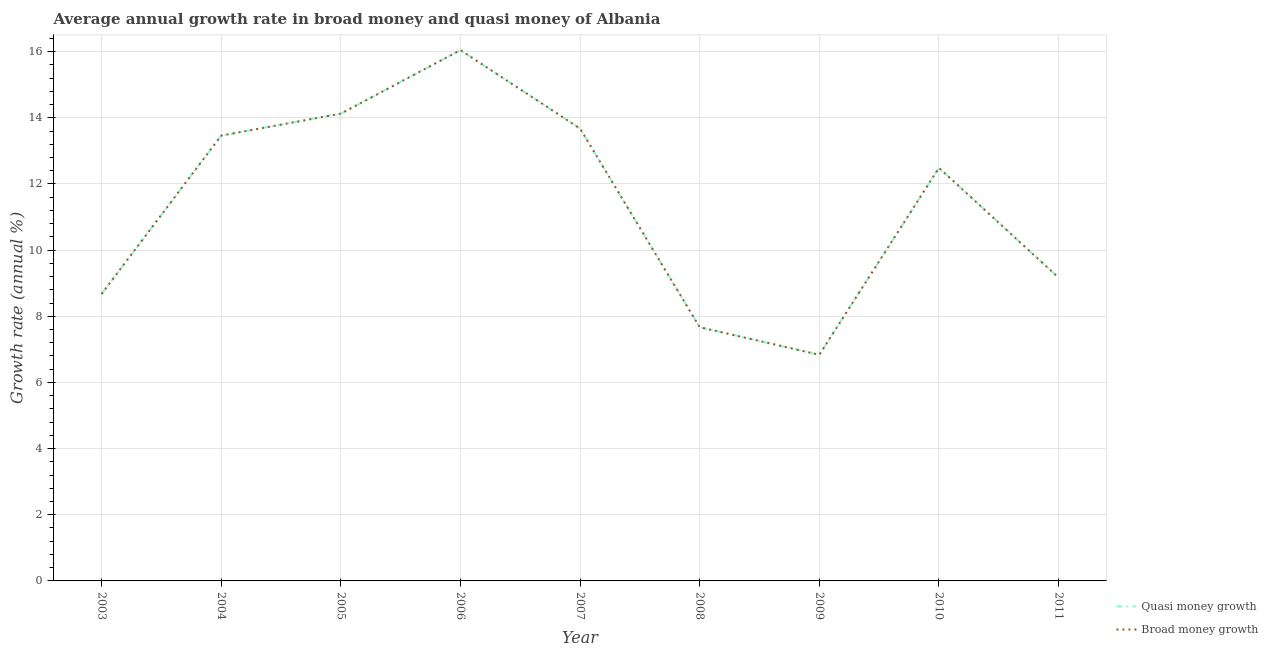Does the line corresponding to annual growth rate in quasi money intersect with the line corresponding to annual growth rate in broad money?
Provide a succinct answer. Yes. Is the number of lines equal to the number of legend labels?
Your response must be concise. Yes. What is the annual growth rate in quasi money in 2009?
Ensure brevity in your answer.  6.84. Across all years, what is the maximum annual growth rate in quasi money?
Offer a terse response. 16.05. Across all years, what is the minimum annual growth rate in quasi money?
Your response must be concise. 6.84. In which year was the annual growth rate in broad money minimum?
Your answer should be compact. 2009. What is the total annual growth rate in quasi money in the graph?
Offer a terse response. 102.14. What is the difference between the annual growth rate in quasi money in 2003 and that in 2004?
Your answer should be compact. -4.79. What is the difference between the annual growth rate in broad money in 2010 and the annual growth rate in quasi money in 2008?
Keep it short and to the point. 4.82. What is the average annual growth rate in broad money per year?
Your response must be concise. 11.35. In the year 2008, what is the difference between the annual growth rate in broad money and annual growth rate in quasi money?
Provide a short and direct response. 0. In how many years, is the annual growth rate in broad money greater than 13.6 %?
Offer a terse response. 3. What is the ratio of the annual growth rate in broad money in 2008 to that in 2009?
Ensure brevity in your answer.  1.12. Is the annual growth rate in quasi money in 2003 less than that in 2009?
Give a very brief answer. No. What is the difference between the highest and the second highest annual growth rate in quasi money?
Your answer should be compact. 1.92. What is the difference between the highest and the lowest annual growth rate in broad money?
Make the answer very short. 9.21. Does the annual growth rate in broad money monotonically increase over the years?
Make the answer very short. No. Is the annual growth rate in broad money strictly greater than the annual growth rate in quasi money over the years?
Keep it short and to the point. No. Is the annual growth rate in quasi money strictly less than the annual growth rate in broad money over the years?
Provide a short and direct response. No. How many lines are there?
Provide a short and direct response. 2. Does the graph contain any zero values?
Offer a very short reply. No. How many legend labels are there?
Ensure brevity in your answer.  2. How are the legend labels stacked?
Your answer should be very brief. Vertical. What is the title of the graph?
Provide a succinct answer. Average annual growth rate in broad money and quasi money of Albania. What is the label or title of the Y-axis?
Make the answer very short. Growth rate (annual %). What is the Growth rate (annual %) in Quasi money growth in 2003?
Ensure brevity in your answer.  8.67. What is the Growth rate (annual %) in Broad money growth in 2003?
Make the answer very short. 8.67. What is the Growth rate (annual %) of Quasi money growth in 2004?
Ensure brevity in your answer.  13.46. What is the Growth rate (annual %) in Broad money growth in 2004?
Offer a very short reply. 13.46. What is the Growth rate (annual %) of Quasi money growth in 2005?
Ensure brevity in your answer.  14.13. What is the Growth rate (annual %) of Broad money growth in 2005?
Offer a very short reply. 14.13. What is the Growth rate (annual %) in Quasi money growth in 2006?
Ensure brevity in your answer.  16.05. What is the Growth rate (annual %) of Broad money growth in 2006?
Provide a succinct answer. 16.05. What is the Growth rate (annual %) in Quasi money growth in 2007?
Provide a succinct answer. 13.67. What is the Growth rate (annual %) in Broad money growth in 2007?
Your response must be concise. 13.67. What is the Growth rate (annual %) in Quasi money growth in 2008?
Your response must be concise. 7.67. What is the Growth rate (annual %) of Broad money growth in 2008?
Your answer should be very brief. 7.67. What is the Growth rate (annual %) of Quasi money growth in 2009?
Keep it short and to the point. 6.84. What is the Growth rate (annual %) of Broad money growth in 2009?
Your answer should be very brief. 6.84. What is the Growth rate (annual %) of Quasi money growth in 2010?
Make the answer very short. 12.49. What is the Growth rate (annual %) of Broad money growth in 2010?
Give a very brief answer. 12.49. What is the Growth rate (annual %) of Quasi money growth in 2011?
Give a very brief answer. 9.17. What is the Growth rate (annual %) of Broad money growth in 2011?
Offer a very short reply. 9.17. Across all years, what is the maximum Growth rate (annual %) in Quasi money growth?
Keep it short and to the point. 16.05. Across all years, what is the maximum Growth rate (annual %) of Broad money growth?
Give a very brief answer. 16.05. Across all years, what is the minimum Growth rate (annual %) of Quasi money growth?
Make the answer very short. 6.84. Across all years, what is the minimum Growth rate (annual %) in Broad money growth?
Give a very brief answer. 6.84. What is the total Growth rate (annual %) in Quasi money growth in the graph?
Provide a succinct answer. 102.14. What is the total Growth rate (annual %) of Broad money growth in the graph?
Offer a very short reply. 102.14. What is the difference between the Growth rate (annual %) of Quasi money growth in 2003 and that in 2004?
Make the answer very short. -4.79. What is the difference between the Growth rate (annual %) of Broad money growth in 2003 and that in 2004?
Ensure brevity in your answer.  -4.79. What is the difference between the Growth rate (annual %) in Quasi money growth in 2003 and that in 2005?
Your response must be concise. -5.45. What is the difference between the Growth rate (annual %) of Broad money growth in 2003 and that in 2005?
Your response must be concise. -5.45. What is the difference between the Growth rate (annual %) of Quasi money growth in 2003 and that in 2006?
Keep it short and to the point. -7.37. What is the difference between the Growth rate (annual %) in Broad money growth in 2003 and that in 2006?
Make the answer very short. -7.37. What is the difference between the Growth rate (annual %) in Quasi money growth in 2003 and that in 2007?
Keep it short and to the point. -5. What is the difference between the Growth rate (annual %) of Broad money growth in 2003 and that in 2007?
Your answer should be compact. -5. What is the difference between the Growth rate (annual %) of Quasi money growth in 2003 and that in 2008?
Give a very brief answer. 1. What is the difference between the Growth rate (annual %) in Broad money growth in 2003 and that in 2008?
Offer a terse response. 1. What is the difference between the Growth rate (annual %) of Quasi money growth in 2003 and that in 2009?
Offer a terse response. 1.84. What is the difference between the Growth rate (annual %) of Broad money growth in 2003 and that in 2009?
Make the answer very short. 1.84. What is the difference between the Growth rate (annual %) of Quasi money growth in 2003 and that in 2010?
Offer a terse response. -3.81. What is the difference between the Growth rate (annual %) in Broad money growth in 2003 and that in 2010?
Your response must be concise. -3.81. What is the difference between the Growth rate (annual %) in Quasi money growth in 2003 and that in 2011?
Keep it short and to the point. -0.49. What is the difference between the Growth rate (annual %) in Broad money growth in 2003 and that in 2011?
Provide a short and direct response. -0.49. What is the difference between the Growth rate (annual %) of Quasi money growth in 2004 and that in 2005?
Give a very brief answer. -0.66. What is the difference between the Growth rate (annual %) of Broad money growth in 2004 and that in 2005?
Offer a terse response. -0.66. What is the difference between the Growth rate (annual %) of Quasi money growth in 2004 and that in 2006?
Offer a terse response. -2.58. What is the difference between the Growth rate (annual %) of Broad money growth in 2004 and that in 2006?
Your answer should be compact. -2.58. What is the difference between the Growth rate (annual %) in Quasi money growth in 2004 and that in 2007?
Offer a very short reply. -0.21. What is the difference between the Growth rate (annual %) of Broad money growth in 2004 and that in 2007?
Offer a terse response. -0.21. What is the difference between the Growth rate (annual %) of Quasi money growth in 2004 and that in 2008?
Offer a terse response. 5.79. What is the difference between the Growth rate (annual %) of Broad money growth in 2004 and that in 2008?
Make the answer very short. 5.79. What is the difference between the Growth rate (annual %) in Quasi money growth in 2004 and that in 2009?
Your answer should be very brief. 6.62. What is the difference between the Growth rate (annual %) in Broad money growth in 2004 and that in 2009?
Your answer should be compact. 6.62. What is the difference between the Growth rate (annual %) of Quasi money growth in 2004 and that in 2010?
Offer a very short reply. 0.97. What is the difference between the Growth rate (annual %) of Broad money growth in 2004 and that in 2010?
Provide a short and direct response. 0.97. What is the difference between the Growth rate (annual %) of Quasi money growth in 2004 and that in 2011?
Provide a succinct answer. 4.29. What is the difference between the Growth rate (annual %) of Broad money growth in 2004 and that in 2011?
Offer a terse response. 4.29. What is the difference between the Growth rate (annual %) of Quasi money growth in 2005 and that in 2006?
Give a very brief answer. -1.92. What is the difference between the Growth rate (annual %) of Broad money growth in 2005 and that in 2006?
Offer a terse response. -1.92. What is the difference between the Growth rate (annual %) in Quasi money growth in 2005 and that in 2007?
Offer a terse response. 0.45. What is the difference between the Growth rate (annual %) in Broad money growth in 2005 and that in 2007?
Offer a terse response. 0.45. What is the difference between the Growth rate (annual %) in Quasi money growth in 2005 and that in 2008?
Ensure brevity in your answer.  6.46. What is the difference between the Growth rate (annual %) in Broad money growth in 2005 and that in 2008?
Your answer should be compact. 6.46. What is the difference between the Growth rate (annual %) in Quasi money growth in 2005 and that in 2009?
Offer a very short reply. 7.29. What is the difference between the Growth rate (annual %) in Broad money growth in 2005 and that in 2009?
Keep it short and to the point. 7.29. What is the difference between the Growth rate (annual %) of Quasi money growth in 2005 and that in 2010?
Keep it short and to the point. 1.64. What is the difference between the Growth rate (annual %) of Broad money growth in 2005 and that in 2010?
Your answer should be very brief. 1.64. What is the difference between the Growth rate (annual %) of Quasi money growth in 2005 and that in 2011?
Your response must be concise. 4.96. What is the difference between the Growth rate (annual %) in Broad money growth in 2005 and that in 2011?
Your response must be concise. 4.96. What is the difference between the Growth rate (annual %) in Quasi money growth in 2006 and that in 2007?
Provide a short and direct response. 2.37. What is the difference between the Growth rate (annual %) in Broad money growth in 2006 and that in 2007?
Make the answer very short. 2.37. What is the difference between the Growth rate (annual %) in Quasi money growth in 2006 and that in 2008?
Give a very brief answer. 8.38. What is the difference between the Growth rate (annual %) of Broad money growth in 2006 and that in 2008?
Your response must be concise. 8.38. What is the difference between the Growth rate (annual %) of Quasi money growth in 2006 and that in 2009?
Give a very brief answer. 9.21. What is the difference between the Growth rate (annual %) of Broad money growth in 2006 and that in 2009?
Offer a terse response. 9.21. What is the difference between the Growth rate (annual %) in Quasi money growth in 2006 and that in 2010?
Your answer should be very brief. 3.56. What is the difference between the Growth rate (annual %) of Broad money growth in 2006 and that in 2010?
Your answer should be compact. 3.56. What is the difference between the Growth rate (annual %) in Quasi money growth in 2006 and that in 2011?
Keep it short and to the point. 6.88. What is the difference between the Growth rate (annual %) of Broad money growth in 2006 and that in 2011?
Give a very brief answer. 6.88. What is the difference between the Growth rate (annual %) in Quasi money growth in 2007 and that in 2008?
Your answer should be compact. 6.01. What is the difference between the Growth rate (annual %) in Broad money growth in 2007 and that in 2008?
Keep it short and to the point. 6.01. What is the difference between the Growth rate (annual %) in Quasi money growth in 2007 and that in 2009?
Give a very brief answer. 6.84. What is the difference between the Growth rate (annual %) of Broad money growth in 2007 and that in 2009?
Your answer should be compact. 6.84. What is the difference between the Growth rate (annual %) in Quasi money growth in 2007 and that in 2010?
Give a very brief answer. 1.19. What is the difference between the Growth rate (annual %) in Broad money growth in 2007 and that in 2010?
Offer a very short reply. 1.19. What is the difference between the Growth rate (annual %) in Quasi money growth in 2007 and that in 2011?
Your answer should be compact. 4.51. What is the difference between the Growth rate (annual %) in Broad money growth in 2007 and that in 2011?
Your answer should be very brief. 4.51. What is the difference between the Growth rate (annual %) of Quasi money growth in 2008 and that in 2009?
Ensure brevity in your answer.  0.83. What is the difference between the Growth rate (annual %) of Broad money growth in 2008 and that in 2009?
Ensure brevity in your answer.  0.83. What is the difference between the Growth rate (annual %) in Quasi money growth in 2008 and that in 2010?
Make the answer very short. -4.82. What is the difference between the Growth rate (annual %) of Broad money growth in 2008 and that in 2010?
Give a very brief answer. -4.82. What is the difference between the Growth rate (annual %) of Quasi money growth in 2008 and that in 2011?
Provide a short and direct response. -1.5. What is the difference between the Growth rate (annual %) of Broad money growth in 2008 and that in 2011?
Your response must be concise. -1.5. What is the difference between the Growth rate (annual %) in Quasi money growth in 2009 and that in 2010?
Ensure brevity in your answer.  -5.65. What is the difference between the Growth rate (annual %) in Broad money growth in 2009 and that in 2010?
Keep it short and to the point. -5.65. What is the difference between the Growth rate (annual %) of Quasi money growth in 2009 and that in 2011?
Your answer should be very brief. -2.33. What is the difference between the Growth rate (annual %) in Broad money growth in 2009 and that in 2011?
Make the answer very short. -2.33. What is the difference between the Growth rate (annual %) in Quasi money growth in 2010 and that in 2011?
Offer a terse response. 3.32. What is the difference between the Growth rate (annual %) in Broad money growth in 2010 and that in 2011?
Offer a very short reply. 3.32. What is the difference between the Growth rate (annual %) of Quasi money growth in 2003 and the Growth rate (annual %) of Broad money growth in 2004?
Your answer should be very brief. -4.79. What is the difference between the Growth rate (annual %) of Quasi money growth in 2003 and the Growth rate (annual %) of Broad money growth in 2005?
Ensure brevity in your answer.  -5.45. What is the difference between the Growth rate (annual %) of Quasi money growth in 2003 and the Growth rate (annual %) of Broad money growth in 2006?
Make the answer very short. -7.37. What is the difference between the Growth rate (annual %) of Quasi money growth in 2003 and the Growth rate (annual %) of Broad money growth in 2007?
Your response must be concise. -5. What is the difference between the Growth rate (annual %) in Quasi money growth in 2003 and the Growth rate (annual %) in Broad money growth in 2008?
Provide a short and direct response. 1. What is the difference between the Growth rate (annual %) in Quasi money growth in 2003 and the Growth rate (annual %) in Broad money growth in 2009?
Your answer should be very brief. 1.84. What is the difference between the Growth rate (annual %) of Quasi money growth in 2003 and the Growth rate (annual %) of Broad money growth in 2010?
Keep it short and to the point. -3.81. What is the difference between the Growth rate (annual %) of Quasi money growth in 2003 and the Growth rate (annual %) of Broad money growth in 2011?
Your answer should be very brief. -0.49. What is the difference between the Growth rate (annual %) in Quasi money growth in 2004 and the Growth rate (annual %) in Broad money growth in 2005?
Your response must be concise. -0.66. What is the difference between the Growth rate (annual %) in Quasi money growth in 2004 and the Growth rate (annual %) in Broad money growth in 2006?
Provide a succinct answer. -2.58. What is the difference between the Growth rate (annual %) of Quasi money growth in 2004 and the Growth rate (annual %) of Broad money growth in 2007?
Provide a succinct answer. -0.21. What is the difference between the Growth rate (annual %) in Quasi money growth in 2004 and the Growth rate (annual %) in Broad money growth in 2008?
Provide a short and direct response. 5.79. What is the difference between the Growth rate (annual %) of Quasi money growth in 2004 and the Growth rate (annual %) of Broad money growth in 2009?
Offer a terse response. 6.62. What is the difference between the Growth rate (annual %) in Quasi money growth in 2004 and the Growth rate (annual %) in Broad money growth in 2010?
Make the answer very short. 0.97. What is the difference between the Growth rate (annual %) in Quasi money growth in 2004 and the Growth rate (annual %) in Broad money growth in 2011?
Offer a terse response. 4.29. What is the difference between the Growth rate (annual %) of Quasi money growth in 2005 and the Growth rate (annual %) of Broad money growth in 2006?
Your response must be concise. -1.92. What is the difference between the Growth rate (annual %) in Quasi money growth in 2005 and the Growth rate (annual %) in Broad money growth in 2007?
Make the answer very short. 0.45. What is the difference between the Growth rate (annual %) in Quasi money growth in 2005 and the Growth rate (annual %) in Broad money growth in 2008?
Keep it short and to the point. 6.46. What is the difference between the Growth rate (annual %) of Quasi money growth in 2005 and the Growth rate (annual %) of Broad money growth in 2009?
Offer a terse response. 7.29. What is the difference between the Growth rate (annual %) of Quasi money growth in 2005 and the Growth rate (annual %) of Broad money growth in 2010?
Your answer should be compact. 1.64. What is the difference between the Growth rate (annual %) of Quasi money growth in 2005 and the Growth rate (annual %) of Broad money growth in 2011?
Ensure brevity in your answer.  4.96. What is the difference between the Growth rate (annual %) in Quasi money growth in 2006 and the Growth rate (annual %) in Broad money growth in 2007?
Offer a very short reply. 2.37. What is the difference between the Growth rate (annual %) in Quasi money growth in 2006 and the Growth rate (annual %) in Broad money growth in 2008?
Ensure brevity in your answer.  8.38. What is the difference between the Growth rate (annual %) in Quasi money growth in 2006 and the Growth rate (annual %) in Broad money growth in 2009?
Make the answer very short. 9.21. What is the difference between the Growth rate (annual %) of Quasi money growth in 2006 and the Growth rate (annual %) of Broad money growth in 2010?
Provide a short and direct response. 3.56. What is the difference between the Growth rate (annual %) in Quasi money growth in 2006 and the Growth rate (annual %) in Broad money growth in 2011?
Keep it short and to the point. 6.88. What is the difference between the Growth rate (annual %) in Quasi money growth in 2007 and the Growth rate (annual %) in Broad money growth in 2008?
Give a very brief answer. 6.01. What is the difference between the Growth rate (annual %) in Quasi money growth in 2007 and the Growth rate (annual %) in Broad money growth in 2009?
Your response must be concise. 6.84. What is the difference between the Growth rate (annual %) of Quasi money growth in 2007 and the Growth rate (annual %) of Broad money growth in 2010?
Offer a terse response. 1.19. What is the difference between the Growth rate (annual %) in Quasi money growth in 2007 and the Growth rate (annual %) in Broad money growth in 2011?
Your response must be concise. 4.51. What is the difference between the Growth rate (annual %) in Quasi money growth in 2008 and the Growth rate (annual %) in Broad money growth in 2009?
Make the answer very short. 0.83. What is the difference between the Growth rate (annual %) of Quasi money growth in 2008 and the Growth rate (annual %) of Broad money growth in 2010?
Your answer should be very brief. -4.82. What is the difference between the Growth rate (annual %) of Quasi money growth in 2008 and the Growth rate (annual %) of Broad money growth in 2011?
Keep it short and to the point. -1.5. What is the difference between the Growth rate (annual %) of Quasi money growth in 2009 and the Growth rate (annual %) of Broad money growth in 2010?
Your answer should be compact. -5.65. What is the difference between the Growth rate (annual %) of Quasi money growth in 2009 and the Growth rate (annual %) of Broad money growth in 2011?
Ensure brevity in your answer.  -2.33. What is the difference between the Growth rate (annual %) in Quasi money growth in 2010 and the Growth rate (annual %) in Broad money growth in 2011?
Make the answer very short. 3.32. What is the average Growth rate (annual %) of Quasi money growth per year?
Your response must be concise. 11.35. What is the average Growth rate (annual %) of Broad money growth per year?
Make the answer very short. 11.35. In the year 2004, what is the difference between the Growth rate (annual %) in Quasi money growth and Growth rate (annual %) in Broad money growth?
Your answer should be compact. 0. In the year 2005, what is the difference between the Growth rate (annual %) in Quasi money growth and Growth rate (annual %) in Broad money growth?
Provide a succinct answer. 0. In the year 2006, what is the difference between the Growth rate (annual %) in Quasi money growth and Growth rate (annual %) in Broad money growth?
Provide a short and direct response. 0. In the year 2008, what is the difference between the Growth rate (annual %) of Quasi money growth and Growth rate (annual %) of Broad money growth?
Provide a succinct answer. 0. In the year 2009, what is the difference between the Growth rate (annual %) of Quasi money growth and Growth rate (annual %) of Broad money growth?
Keep it short and to the point. 0. In the year 2011, what is the difference between the Growth rate (annual %) in Quasi money growth and Growth rate (annual %) in Broad money growth?
Make the answer very short. 0. What is the ratio of the Growth rate (annual %) in Quasi money growth in 2003 to that in 2004?
Ensure brevity in your answer.  0.64. What is the ratio of the Growth rate (annual %) in Broad money growth in 2003 to that in 2004?
Your answer should be very brief. 0.64. What is the ratio of the Growth rate (annual %) in Quasi money growth in 2003 to that in 2005?
Make the answer very short. 0.61. What is the ratio of the Growth rate (annual %) in Broad money growth in 2003 to that in 2005?
Your response must be concise. 0.61. What is the ratio of the Growth rate (annual %) in Quasi money growth in 2003 to that in 2006?
Your answer should be very brief. 0.54. What is the ratio of the Growth rate (annual %) in Broad money growth in 2003 to that in 2006?
Make the answer very short. 0.54. What is the ratio of the Growth rate (annual %) of Quasi money growth in 2003 to that in 2007?
Give a very brief answer. 0.63. What is the ratio of the Growth rate (annual %) of Broad money growth in 2003 to that in 2007?
Offer a terse response. 0.63. What is the ratio of the Growth rate (annual %) of Quasi money growth in 2003 to that in 2008?
Offer a very short reply. 1.13. What is the ratio of the Growth rate (annual %) in Broad money growth in 2003 to that in 2008?
Make the answer very short. 1.13. What is the ratio of the Growth rate (annual %) of Quasi money growth in 2003 to that in 2009?
Your answer should be compact. 1.27. What is the ratio of the Growth rate (annual %) in Broad money growth in 2003 to that in 2009?
Your response must be concise. 1.27. What is the ratio of the Growth rate (annual %) of Quasi money growth in 2003 to that in 2010?
Provide a short and direct response. 0.69. What is the ratio of the Growth rate (annual %) of Broad money growth in 2003 to that in 2010?
Offer a very short reply. 0.69. What is the ratio of the Growth rate (annual %) in Quasi money growth in 2003 to that in 2011?
Keep it short and to the point. 0.95. What is the ratio of the Growth rate (annual %) of Broad money growth in 2003 to that in 2011?
Give a very brief answer. 0.95. What is the ratio of the Growth rate (annual %) of Quasi money growth in 2004 to that in 2005?
Give a very brief answer. 0.95. What is the ratio of the Growth rate (annual %) of Broad money growth in 2004 to that in 2005?
Your response must be concise. 0.95. What is the ratio of the Growth rate (annual %) of Quasi money growth in 2004 to that in 2006?
Give a very brief answer. 0.84. What is the ratio of the Growth rate (annual %) of Broad money growth in 2004 to that in 2006?
Give a very brief answer. 0.84. What is the ratio of the Growth rate (annual %) in Quasi money growth in 2004 to that in 2007?
Make the answer very short. 0.98. What is the ratio of the Growth rate (annual %) in Broad money growth in 2004 to that in 2007?
Offer a very short reply. 0.98. What is the ratio of the Growth rate (annual %) in Quasi money growth in 2004 to that in 2008?
Offer a very short reply. 1.76. What is the ratio of the Growth rate (annual %) of Broad money growth in 2004 to that in 2008?
Offer a terse response. 1.76. What is the ratio of the Growth rate (annual %) in Quasi money growth in 2004 to that in 2009?
Your answer should be very brief. 1.97. What is the ratio of the Growth rate (annual %) of Broad money growth in 2004 to that in 2009?
Your answer should be very brief. 1.97. What is the ratio of the Growth rate (annual %) of Quasi money growth in 2004 to that in 2010?
Provide a succinct answer. 1.08. What is the ratio of the Growth rate (annual %) of Broad money growth in 2004 to that in 2010?
Ensure brevity in your answer.  1.08. What is the ratio of the Growth rate (annual %) in Quasi money growth in 2004 to that in 2011?
Your answer should be very brief. 1.47. What is the ratio of the Growth rate (annual %) of Broad money growth in 2004 to that in 2011?
Give a very brief answer. 1.47. What is the ratio of the Growth rate (annual %) of Quasi money growth in 2005 to that in 2006?
Provide a succinct answer. 0.88. What is the ratio of the Growth rate (annual %) of Broad money growth in 2005 to that in 2006?
Ensure brevity in your answer.  0.88. What is the ratio of the Growth rate (annual %) of Quasi money growth in 2005 to that in 2007?
Provide a succinct answer. 1.03. What is the ratio of the Growth rate (annual %) of Broad money growth in 2005 to that in 2007?
Keep it short and to the point. 1.03. What is the ratio of the Growth rate (annual %) in Quasi money growth in 2005 to that in 2008?
Provide a short and direct response. 1.84. What is the ratio of the Growth rate (annual %) in Broad money growth in 2005 to that in 2008?
Offer a terse response. 1.84. What is the ratio of the Growth rate (annual %) in Quasi money growth in 2005 to that in 2009?
Offer a very short reply. 2.07. What is the ratio of the Growth rate (annual %) in Broad money growth in 2005 to that in 2009?
Keep it short and to the point. 2.07. What is the ratio of the Growth rate (annual %) in Quasi money growth in 2005 to that in 2010?
Offer a terse response. 1.13. What is the ratio of the Growth rate (annual %) in Broad money growth in 2005 to that in 2010?
Keep it short and to the point. 1.13. What is the ratio of the Growth rate (annual %) in Quasi money growth in 2005 to that in 2011?
Your answer should be compact. 1.54. What is the ratio of the Growth rate (annual %) of Broad money growth in 2005 to that in 2011?
Keep it short and to the point. 1.54. What is the ratio of the Growth rate (annual %) in Quasi money growth in 2006 to that in 2007?
Your response must be concise. 1.17. What is the ratio of the Growth rate (annual %) of Broad money growth in 2006 to that in 2007?
Give a very brief answer. 1.17. What is the ratio of the Growth rate (annual %) in Quasi money growth in 2006 to that in 2008?
Provide a succinct answer. 2.09. What is the ratio of the Growth rate (annual %) of Broad money growth in 2006 to that in 2008?
Your response must be concise. 2.09. What is the ratio of the Growth rate (annual %) in Quasi money growth in 2006 to that in 2009?
Make the answer very short. 2.35. What is the ratio of the Growth rate (annual %) of Broad money growth in 2006 to that in 2009?
Offer a very short reply. 2.35. What is the ratio of the Growth rate (annual %) in Quasi money growth in 2006 to that in 2010?
Make the answer very short. 1.29. What is the ratio of the Growth rate (annual %) in Broad money growth in 2006 to that in 2010?
Provide a short and direct response. 1.29. What is the ratio of the Growth rate (annual %) in Quasi money growth in 2006 to that in 2011?
Your response must be concise. 1.75. What is the ratio of the Growth rate (annual %) in Broad money growth in 2006 to that in 2011?
Offer a terse response. 1.75. What is the ratio of the Growth rate (annual %) of Quasi money growth in 2007 to that in 2008?
Your answer should be very brief. 1.78. What is the ratio of the Growth rate (annual %) in Broad money growth in 2007 to that in 2008?
Your answer should be compact. 1.78. What is the ratio of the Growth rate (annual %) in Quasi money growth in 2007 to that in 2009?
Provide a short and direct response. 2. What is the ratio of the Growth rate (annual %) of Broad money growth in 2007 to that in 2009?
Offer a very short reply. 2. What is the ratio of the Growth rate (annual %) of Quasi money growth in 2007 to that in 2010?
Your response must be concise. 1.1. What is the ratio of the Growth rate (annual %) of Broad money growth in 2007 to that in 2010?
Keep it short and to the point. 1.1. What is the ratio of the Growth rate (annual %) of Quasi money growth in 2007 to that in 2011?
Keep it short and to the point. 1.49. What is the ratio of the Growth rate (annual %) in Broad money growth in 2007 to that in 2011?
Provide a short and direct response. 1.49. What is the ratio of the Growth rate (annual %) in Quasi money growth in 2008 to that in 2009?
Ensure brevity in your answer.  1.12. What is the ratio of the Growth rate (annual %) of Broad money growth in 2008 to that in 2009?
Give a very brief answer. 1.12. What is the ratio of the Growth rate (annual %) of Quasi money growth in 2008 to that in 2010?
Your answer should be very brief. 0.61. What is the ratio of the Growth rate (annual %) in Broad money growth in 2008 to that in 2010?
Offer a very short reply. 0.61. What is the ratio of the Growth rate (annual %) in Quasi money growth in 2008 to that in 2011?
Keep it short and to the point. 0.84. What is the ratio of the Growth rate (annual %) of Broad money growth in 2008 to that in 2011?
Your response must be concise. 0.84. What is the ratio of the Growth rate (annual %) of Quasi money growth in 2009 to that in 2010?
Provide a short and direct response. 0.55. What is the ratio of the Growth rate (annual %) in Broad money growth in 2009 to that in 2010?
Offer a very short reply. 0.55. What is the ratio of the Growth rate (annual %) of Quasi money growth in 2009 to that in 2011?
Ensure brevity in your answer.  0.75. What is the ratio of the Growth rate (annual %) in Broad money growth in 2009 to that in 2011?
Keep it short and to the point. 0.75. What is the ratio of the Growth rate (annual %) in Quasi money growth in 2010 to that in 2011?
Your answer should be very brief. 1.36. What is the ratio of the Growth rate (annual %) in Broad money growth in 2010 to that in 2011?
Your response must be concise. 1.36. What is the difference between the highest and the second highest Growth rate (annual %) in Quasi money growth?
Make the answer very short. 1.92. What is the difference between the highest and the second highest Growth rate (annual %) in Broad money growth?
Give a very brief answer. 1.92. What is the difference between the highest and the lowest Growth rate (annual %) in Quasi money growth?
Make the answer very short. 9.21. What is the difference between the highest and the lowest Growth rate (annual %) in Broad money growth?
Give a very brief answer. 9.21. 